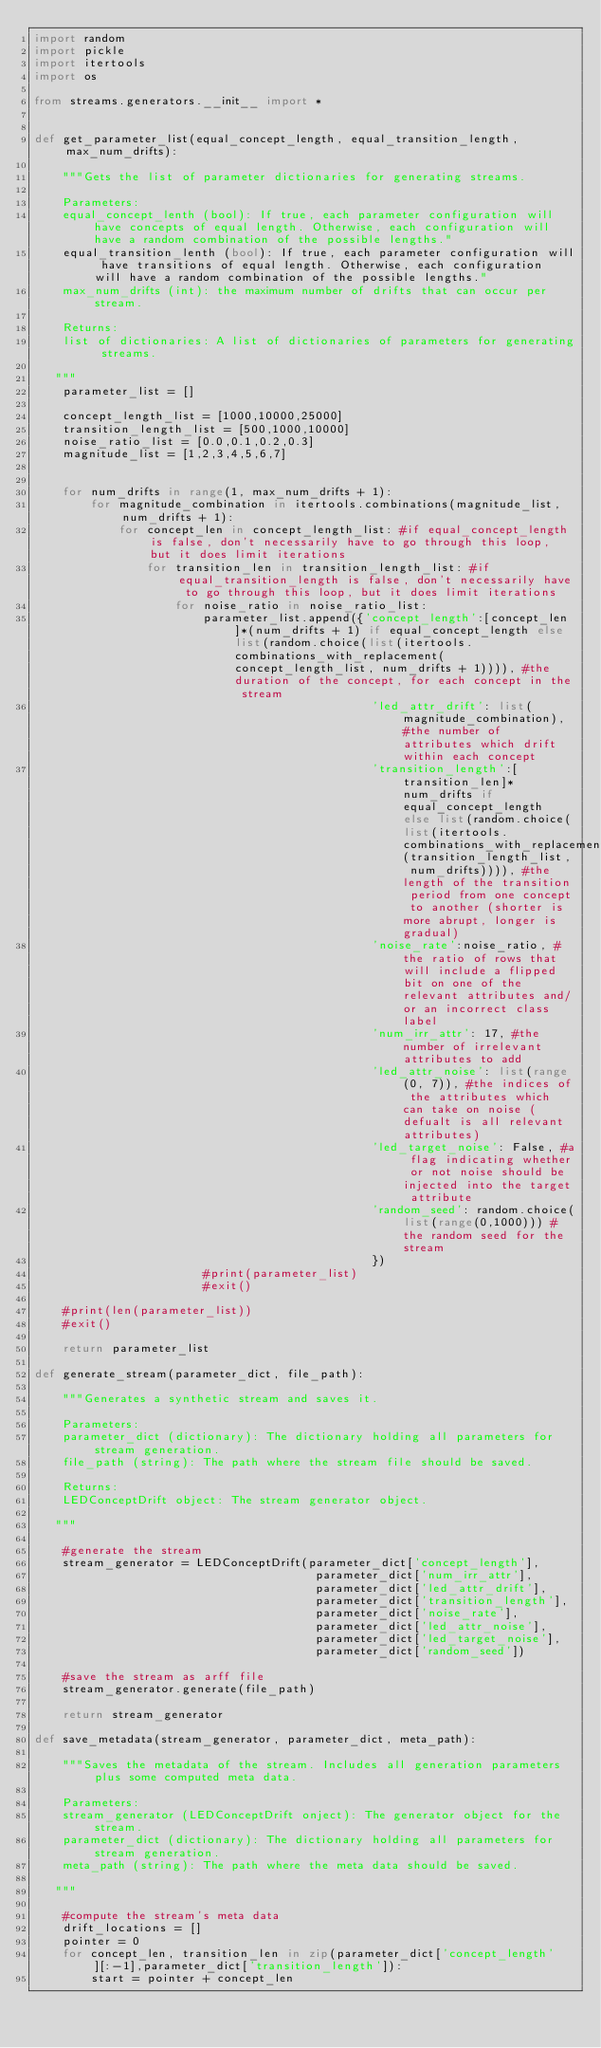Convert code to text. <code><loc_0><loc_0><loc_500><loc_500><_Python_>import random
import pickle
import itertools
import os

from streams.generators.__init__ import *


def get_parameter_list(equal_concept_length, equal_transition_length, max_num_drifts):

    """Gets the list of parameter dictionaries for generating streams.

    Parameters:
    equal_concept_lenth (bool): If true, each parameter configuration will have concepts of equal length. Otherwise, each configuration will have a random combination of the possible lengths."
    equal_transition_lenth (bool): If true, each parameter configuration will have transitions of equal length. Otherwise, each configuration will have a random combination of the possible lengths."
    max_num_drifts (int): the maximum number of drifts that can occur per stream.

    Returns:
    list of dictionaries: A list of dictionaries of parameters for generating streams.

   """
    parameter_list = []

    concept_length_list = [1000,10000,25000]
    transition_length_list = [500,1000,10000]
    noise_ratio_list = [0.0,0.1,0.2,0.3]
    magnitude_list = [1,2,3,4,5,6,7]


    for num_drifts in range(1, max_num_drifts + 1):
        for magnitude_combination in itertools.combinations(magnitude_list, num_drifts + 1):  
            for concept_len in concept_length_list: #if equal_concept_length is false, don't necessarily have to go through this loop, but it does limit iterations
                for transition_len in transition_length_list: #if equal_transition_length is false, don't necessarily have to go through this loop, but it does limit iterations
                    for noise_ratio in noise_ratio_list:
                        parameter_list.append({'concept_length':[concept_len]*(num_drifts + 1) if equal_concept_length else list(random.choice(list(itertools.combinations_with_replacement(concept_length_list, num_drifts + 1)))), #the duration of the concept, for each concept in the stream
                                                'led_attr_drift': list(magnitude_combination), #the number of attributes which drift within each concept
                                                'transition_length':[transition_len]*num_drifts if equal_concept_length else list(random.choice(list(itertools.combinations_with_replacement(transition_length_list, num_drifts)))), #the length of the transition period from one concept to another (shorter is more abrupt, longer is gradual)
                                                'noise_rate':noise_ratio, #the ratio of rows that will include a flipped bit on one of the relevant attributes and/or an incorrect class label
                                                'num_irr_attr': 17, #the number of irrelevant attributes to add
                                                'led_attr_noise': list(range(0, 7)), #the indices of the attributes which can take on noise (defualt is all relevant attributes)
                                                'led_target_noise': False, #a flag indicating whether or not noise should be injected into the target attribute
                                                'random_seed': random.choice(list(range(0,1000))) #the random seed for the stream
                                                })
                        #print(parameter_list)
                        #exit()

    #print(len(parameter_list))
    #exit()

    return parameter_list

def generate_stream(parameter_dict, file_path):

    """Generates a synthetic stream and saves it.

    Parameters:
    parameter_dict (dictionary): The dictionary holding all parameters for stream generation.
    file_path (string): The path where the stream file should be saved.

    Returns:
    LEDConceptDrift object: The stream generator object.

   """

    #generate the stream
    stream_generator = LEDConceptDrift(parameter_dict['concept_length'], 
                                        parameter_dict['num_irr_attr'], 
                                        parameter_dict['led_attr_drift'],
                                        parameter_dict['transition_length'],
                                        parameter_dict['noise_rate'],
                                        parameter_dict['led_attr_noise'],
                                        parameter_dict['led_target_noise'],
                                        parameter_dict['random_seed'])

    #save the stream as arff file
    stream_generator.generate(file_path)

    return stream_generator

def save_metadata(stream_generator, parameter_dict, meta_path):

    """Saves the metadata of the stream. Includes all generation parameters plus some computed meta data.

    Parameters:
    stream_generator (LEDConceptDrift onject): The generator object for the stream.
    parameter_dict (dictionary): The dictionary holding all parameters for stream generation.
    meta_path (string): The path where the meta data should be saved.

   """

    #compute the stream's meta data
    drift_locations = []
    pointer = 0
    for concept_len, transition_len in zip(parameter_dict['concept_length'][:-1],parameter_dict['transition_length']):
        start = pointer + concept_len</code> 